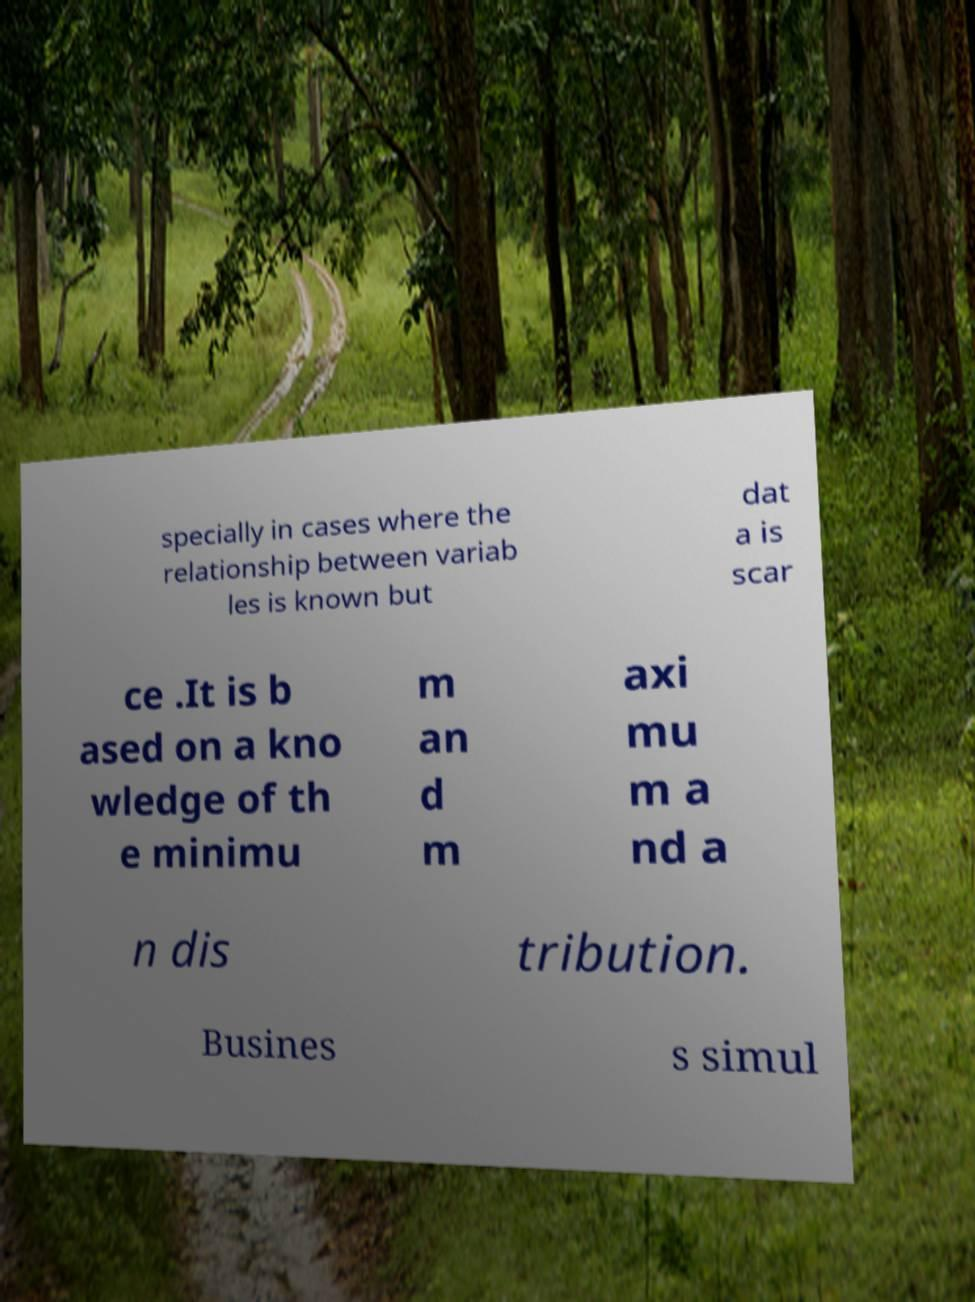There's text embedded in this image that I need extracted. Can you transcribe it verbatim? specially in cases where the relationship between variab les is known but dat a is scar ce .It is b ased on a kno wledge of th e minimu m an d m axi mu m a nd a n dis tribution. Busines s simul 